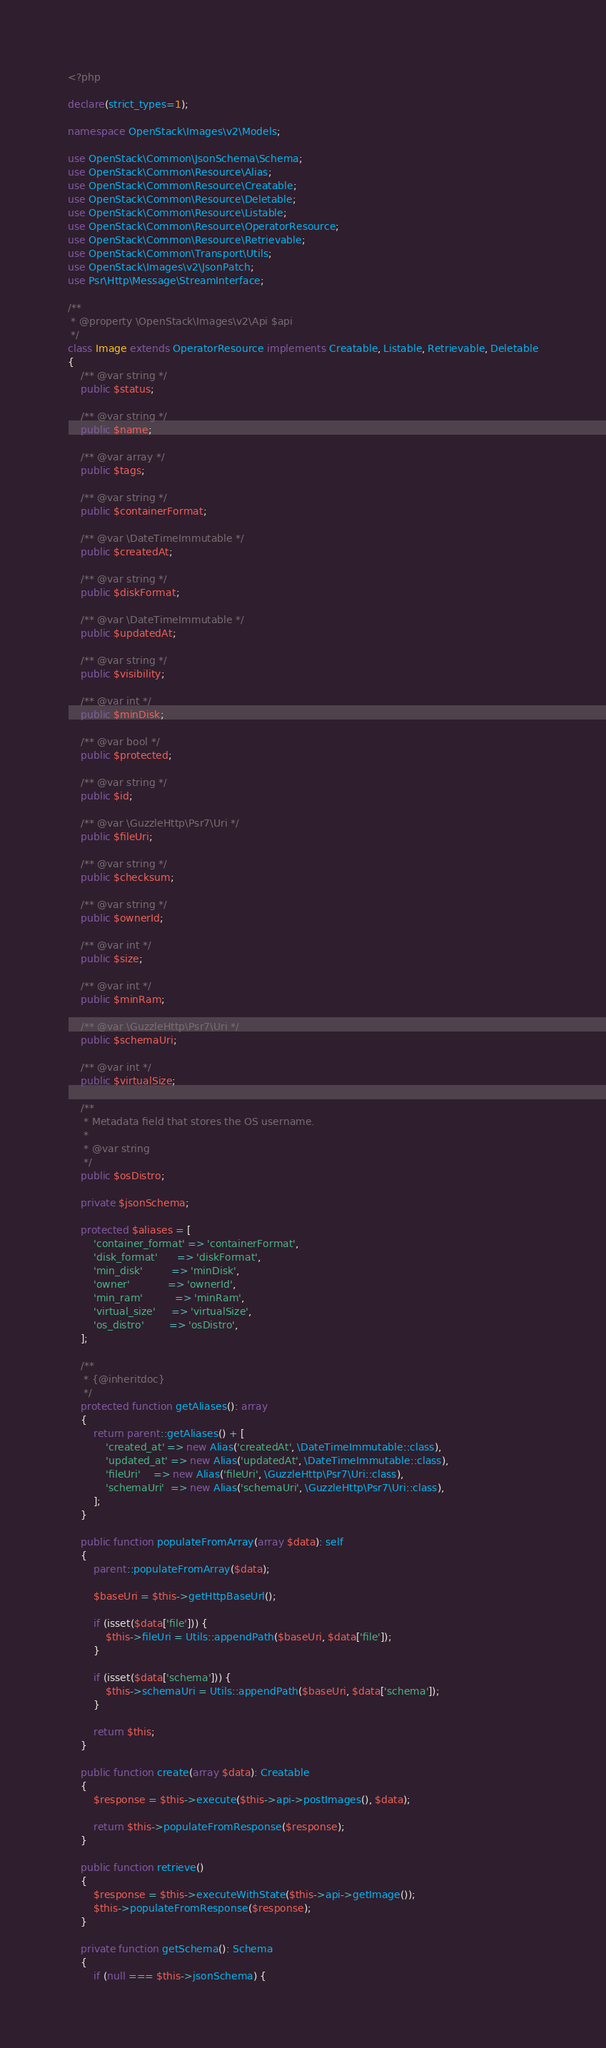<code> <loc_0><loc_0><loc_500><loc_500><_PHP_><?php

declare(strict_types=1);

namespace OpenStack\Images\v2\Models;

use OpenStack\Common\JsonSchema\Schema;
use OpenStack\Common\Resource\Alias;
use OpenStack\Common\Resource\Creatable;
use OpenStack\Common\Resource\Deletable;
use OpenStack\Common\Resource\Listable;
use OpenStack\Common\Resource\OperatorResource;
use OpenStack\Common\Resource\Retrievable;
use OpenStack\Common\Transport\Utils;
use OpenStack\Images\v2\JsonPatch;
use Psr\Http\Message\StreamInterface;

/**
 * @property \OpenStack\Images\v2\Api $api
 */
class Image extends OperatorResource implements Creatable, Listable, Retrievable, Deletable
{
    /** @var string */
    public $status;

    /** @var string */
    public $name;

    /** @var array */
    public $tags;

    /** @var string */
    public $containerFormat;

    /** @var \DateTimeImmutable */
    public $createdAt;

    /** @var string */
    public $diskFormat;

    /** @var \DateTimeImmutable */
    public $updatedAt;

    /** @var string */
    public $visibility;

    /** @var int */
    public $minDisk;

    /** @var bool */
    public $protected;

    /** @var string */
    public $id;

    /** @var \GuzzleHttp\Psr7\Uri */
    public $fileUri;

    /** @var string */
    public $checksum;

    /** @var string */
    public $ownerId;

    /** @var int */
    public $size;

    /** @var int */
    public $minRam;

    /** @var \GuzzleHttp\Psr7\Uri */
    public $schemaUri;

    /** @var int */
    public $virtualSize;

    /**
     * Metadata field that stores the OS username.
     *
     * @var string
     */
    public $osDistro;

    private $jsonSchema;

    protected $aliases = [
        'container_format' => 'containerFormat',
        'disk_format'      => 'diskFormat',
        'min_disk'         => 'minDisk',
        'owner'            => 'ownerId',
        'min_ram'          => 'minRam',
        'virtual_size'     => 'virtualSize',
        'os_distro'        => 'osDistro',
    ];

    /**
     * {@inheritdoc}
     */
    protected function getAliases(): array
    {
        return parent::getAliases() + [
            'created_at' => new Alias('createdAt', \DateTimeImmutable::class),
            'updated_at' => new Alias('updatedAt', \DateTimeImmutable::class),
            'fileUri'    => new Alias('fileUri', \GuzzleHttp\Psr7\Uri::class),
            'schemaUri'  => new Alias('schemaUri', \GuzzleHttp\Psr7\Uri::class),
        ];
    }

    public function populateFromArray(array $data): self
    {
        parent::populateFromArray($data);

        $baseUri = $this->getHttpBaseUrl();

        if (isset($data['file'])) {
            $this->fileUri = Utils::appendPath($baseUri, $data['file']);
        }

        if (isset($data['schema'])) {
            $this->schemaUri = Utils::appendPath($baseUri, $data['schema']);
        }

        return $this;
    }

    public function create(array $data): Creatable
    {
        $response = $this->execute($this->api->postImages(), $data);

        return $this->populateFromResponse($response);
    }

    public function retrieve()
    {
        $response = $this->executeWithState($this->api->getImage());
        $this->populateFromResponse($response);
    }

    private function getSchema(): Schema
    {
        if (null === $this->jsonSchema) {</code> 